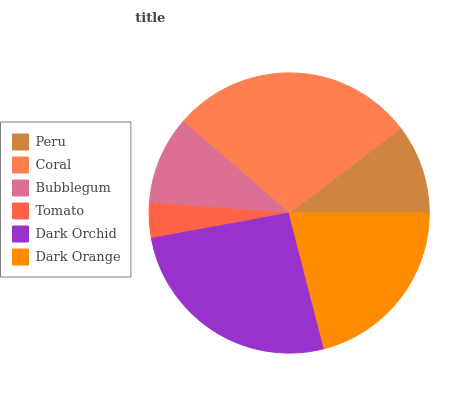Is Tomato the minimum?
Answer yes or no. Yes. Is Coral the maximum?
Answer yes or no. Yes. Is Bubblegum the minimum?
Answer yes or no. No. Is Bubblegum the maximum?
Answer yes or no. No. Is Coral greater than Bubblegum?
Answer yes or no. Yes. Is Bubblegum less than Coral?
Answer yes or no. Yes. Is Bubblegum greater than Coral?
Answer yes or no. No. Is Coral less than Bubblegum?
Answer yes or no. No. Is Dark Orange the high median?
Answer yes or no. Yes. Is Peru the low median?
Answer yes or no. Yes. Is Dark Orchid the high median?
Answer yes or no. No. Is Tomato the low median?
Answer yes or no. No. 